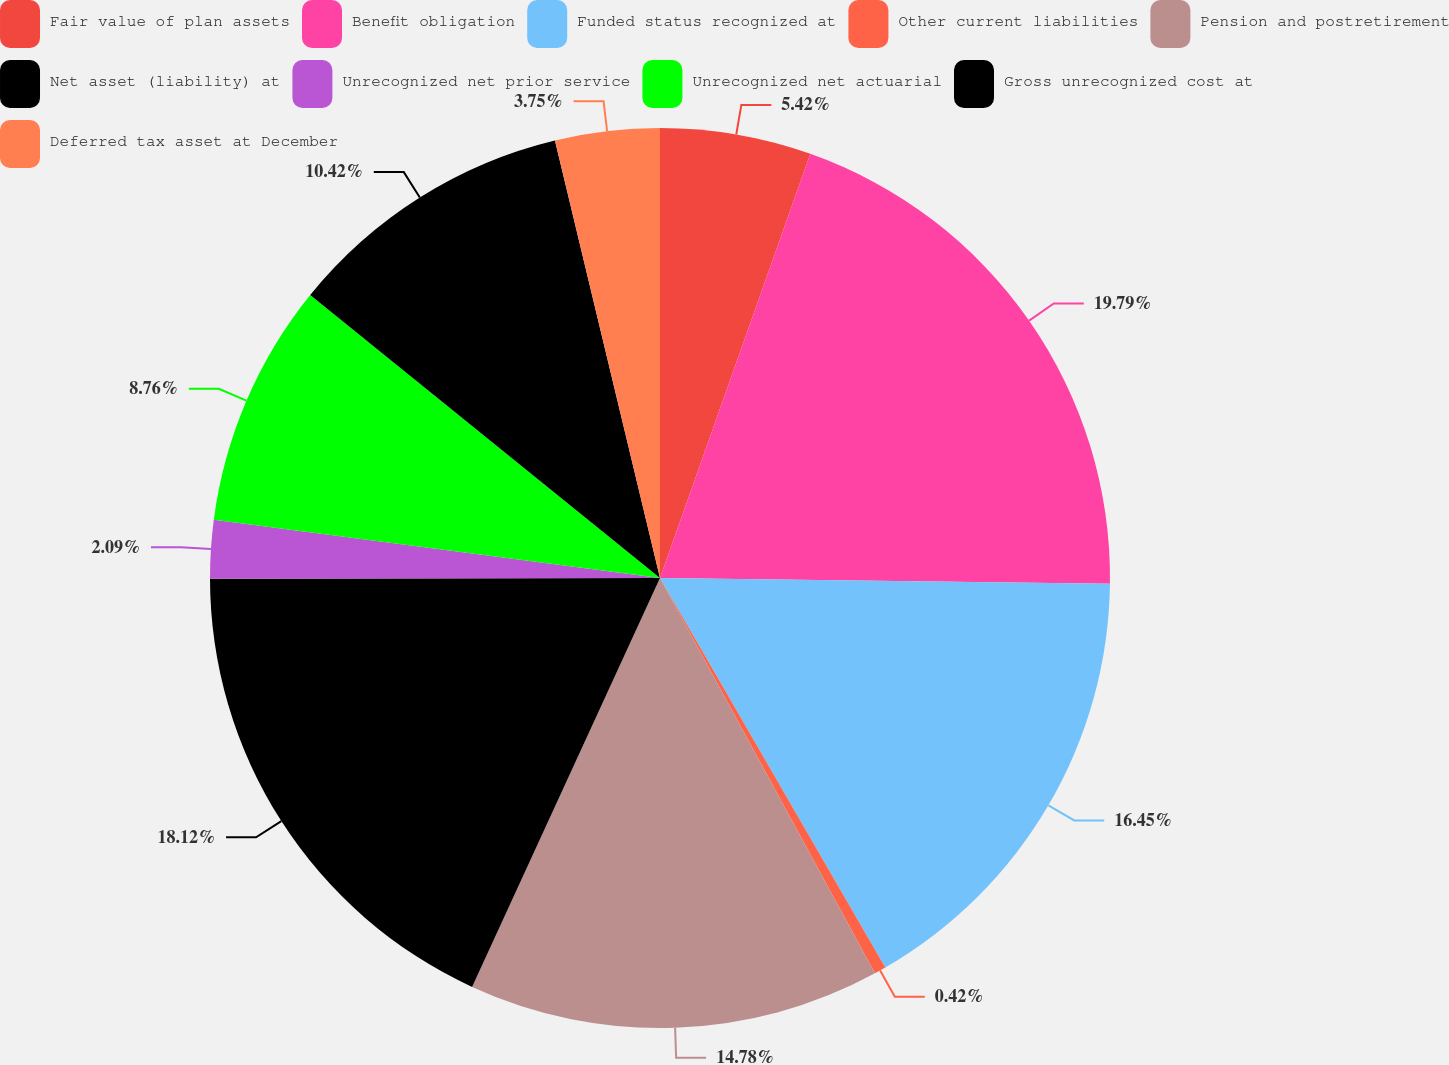Convert chart to OTSL. <chart><loc_0><loc_0><loc_500><loc_500><pie_chart><fcel>Fair value of plan assets<fcel>Benefit obligation<fcel>Funded status recognized at<fcel>Other current liabilities<fcel>Pension and postretirement<fcel>Net asset (liability) at<fcel>Unrecognized net prior service<fcel>Unrecognized net actuarial<fcel>Gross unrecognized cost at<fcel>Deferred tax asset at December<nl><fcel>5.42%<fcel>19.78%<fcel>16.45%<fcel>0.42%<fcel>14.78%<fcel>18.12%<fcel>2.09%<fcel>8.76%<fcel>10.42%<fcel>3.75%<nl></chart> 